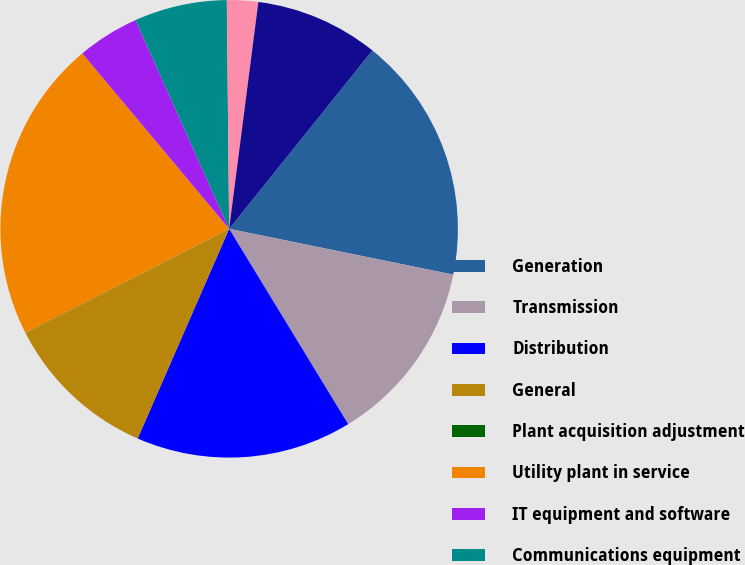Convert chart. <chart><loc_0><loc_0><loc_500><loc_500><pie_chart><fcel>Generation<fcel>Transmission<fcel>Distribution<fcel>General<fcel>Plant acquisition adjustment<fcel>Utility plant in service<fcel>IT equipment and software<fcel>Communications equipment<fcel>Other<fcel>Other plant in service<nl><fcel>17.44%<fcel>13.08%<fcel>15.26%<fcel>10.91%<fcel>0.02%<fcel>21.43%<fcel>4.38%<fcel>6.55%<fcel>2.2%<fcel>8.73%<nl></chart> 